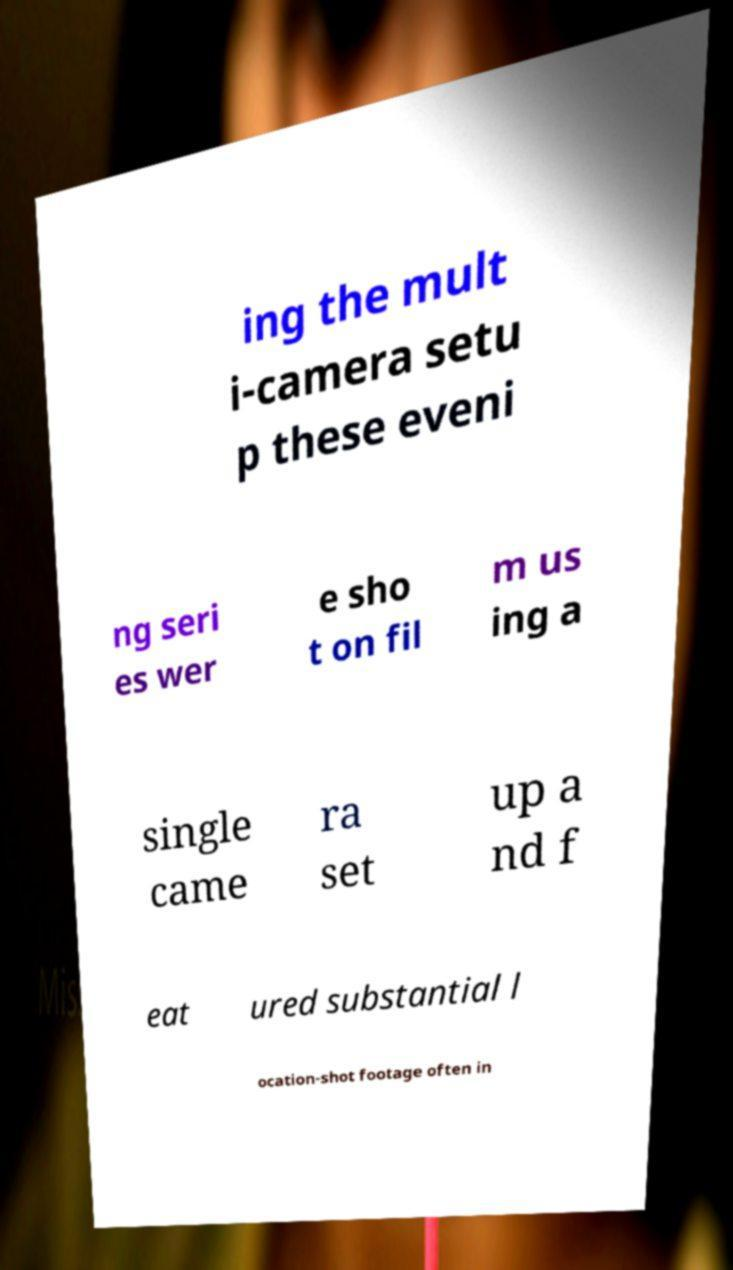I need the written content from this picture converted into text. Can you do that? ing the mult i-camera setu p these eveni ng seri es wer e sho t on fil m us ing a single came ra set up a nd f eat ured substantial l ocation-shot footage often in 